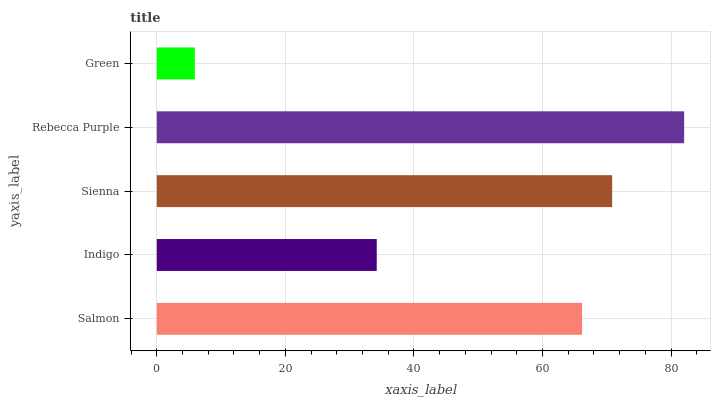Is Green the minimum?
Answer yes or no. Yes. Is Rebecca Purple the maximum?
Answer yes or no. Yes. Is Indigo the minimum?
Answer yes or no. No. Is Indigo the maximum?
Answer yes or no. No. Is Salmon greater than Indigo?
Answer yes or no. Yes. Is Indigo less than Salmon?
Answer yes or no. Yes. Is Indigo greater than Salmon?
Answer yes or no. No. Is Salmon less than Indigo?
Answer yes or no. No. Is Salmon the high median?
Answer yes or no. Yes. Is Salmon the low median?
Answer yes or no. Yes. Is Green the high median?
Answer yes or no. No. Is Indigo the low median?
Answer yes or no. No. 